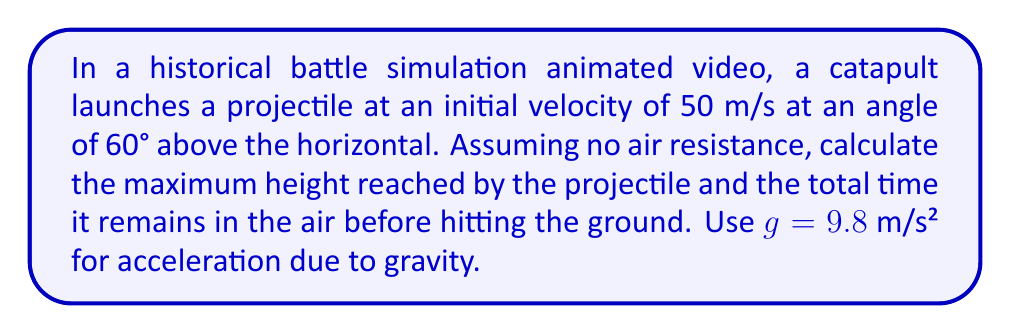Can you solve this math problem? To solve this problem, we'll use the equations of motion for projectile motion. Let's break it down step by step:

1. Given information:
   - Initial velocity, $v_0 = 50$ m/s
   - Launch angle, $\theta = 60°$
   - Acceleration due to gravity, $g = 9.8$ m/s²

2. Calculate the initial vertical and horizontal components of velocity:
   $v_{0y} = v_0 \sin(\theta) = 50 \sin(60°) = 43.3$ m/s
   $v_{0x} = v_0 \cos(\theta) = 50 \cos(60°) = 25$ m/s

3. Maximum height:
   The maximum height is reached when the vertical velocity becomes zero.
   Using the equation $v_y^2 = v_{0y}^2 - 2gh_{max}$, where $v_y = 0$ at the highest point:
   
   $$0 = (43.3)^2 - 2(9.8)h_{max}$$
   $$h_{max} = \frac{(43.3)^2}{2(9.8)} = 95.6$ m$$

4. Time to reach maximum height:
   Using the equation $v_y = v_{0y} - gt$, where $v_y = 0$ at the highest point:
   
   $$0 = 43.3 - 9.8t$$
   $$t_{up} = \frac{43.3}{9.8} = 4.42$ s$$

5. Total time in the air:
   The total time is twice the time to reach the maximum height (time up + time down):
   
   $$t_{total} = 2t_{up} = 2(4.42) = 8.84$ s$$

Therefore, the maximum height reached by the projectile is 95.6 meters, and the total time it remains in the air is 8.84 seconds.
Answer: Maximum height: 95.6 m
Total time in air: 8.84 s 